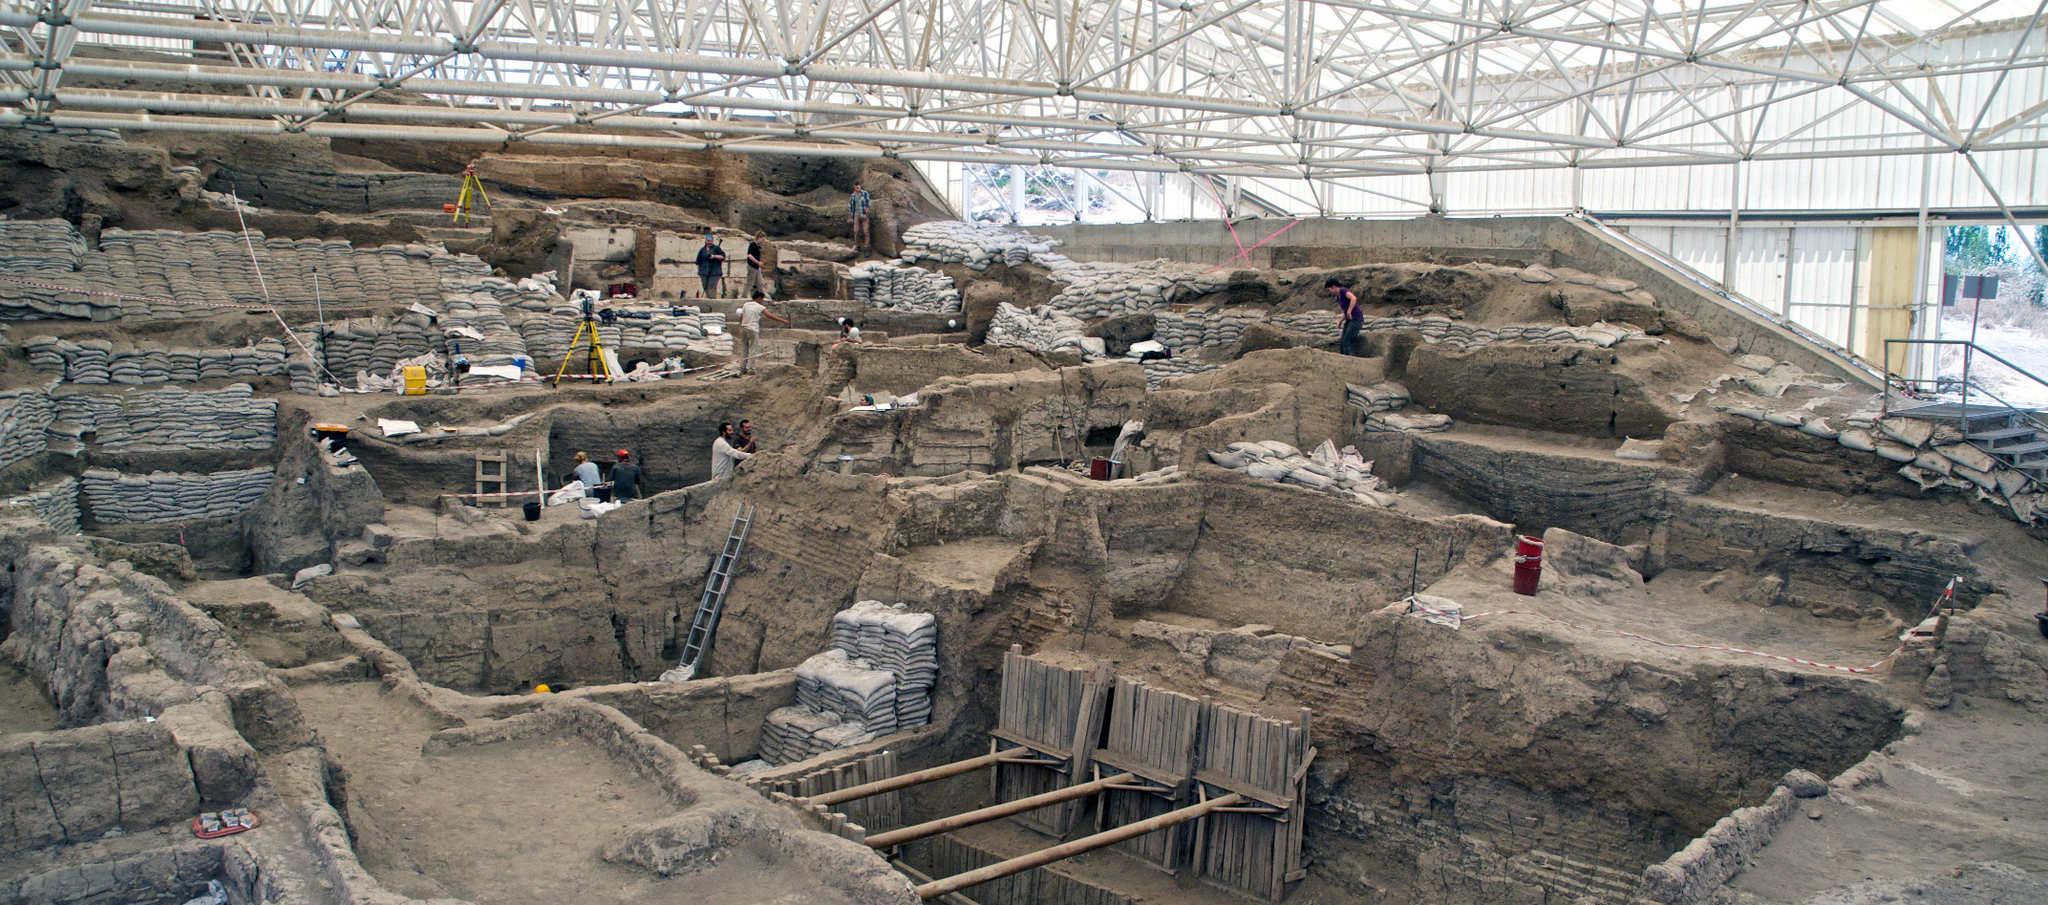How is the excavation at Catalhoyuk conducted to ensure the preservation of the archaeological findings? The excavation at Catalhoyuk is performed with meticulous care to preserve the integrity and informational value of the site. Techniques include careful layer-by-layer removal using fine tools, detailed documentation of each finding, and immediate coverage of unearthed segments to protect them from environmental elements. Specialists in various fields, such as pottery, bone analysis, and sediment examination, collaborate closely to analyze materials on-site, ensuring a holistic understanding of the context and period. 